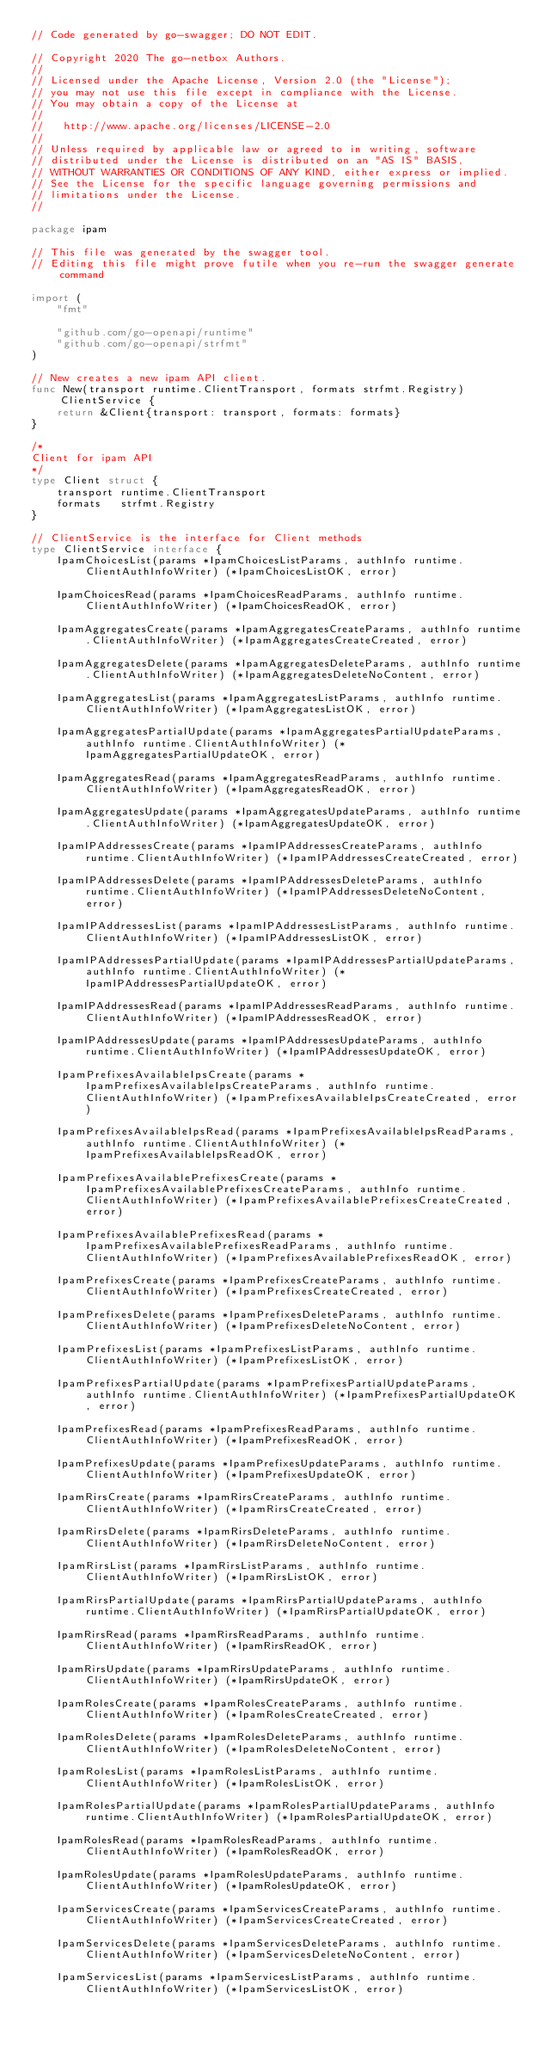<code> <loc_0><loc_0><loc_500><loc_500><_Go_>// Code generated by go-swagger; DO NOT EDIT.

// Copyright 2020 The go-netbox Authors.
//
// Licensed under the Apache License, Version 2.0 (the "License");
// you may not use this file except in compliance with the License.
// You may obtain a copy of the License at
//
//   http://www.apache.org/licenses/LICENSE-2.0
//
// Unless required by applicable law or agreed to in writing, software
// distributed under the License is distributed on an "AS IS" BASIS,
// WITHOUT WARRANTIES OR CONDITIONS OF ANY KIND, either express or implied.
// See the License for the specific language governing permissions and
// limitations under the License.
//

package ipam

// This file was generated by the swagger tool.
// Editing this file might prove futile when you re-run the swagger generate command

import (
	"fmt"

	"github.com/go-openapi/runtime"
	"github.com/go-openapi/strfmt"
)

// New creates a new ipam API client.
func New(transport runtime.ClientTransport, formats strfmt.Registry) ClientService {
	return &Client{transport: transport, formats: formats}
}

/*
Client for ipam API
*/
type Client struct {
	transport runtime.ClientTransport
	formats   strfmt.Registry
}

// ClientService is the interface for Client methods
type ClientService interface {
	IpamChoicesList(params *IpamChoicesListParams, authInfo runtime.ClientAuthInfoWriter) (*IpamChoicesListOK, error)

	IpamChoicesRead(params *IpamChoicesReadParams, authInfo runtime.ClientAuthInfoWriter) (*IpamChoicesReadOK, error)

	IpamAggregatesCreate(params *IpamAggregatesCreateParams, authInfo runtime.ClientAuthInfoWriter) (*IpamAggregatesCreateCreated, error)

	IpamAggregatesDelete(params *IpamAggregatesDeleteParams, authInfo runtime.ClientAuthInfoWriter) (*IpamAggregatesDeleteNoContent, error)

	IpamAggregatesList(params *IpamAggregatesListParams, authInfo runtime.ClientAuthInfoWriter) (*IpamAggregatesListOK, error)

	IpamAggregatesPartialUpdate(params *IpamAggregatesPartialUpdateParams, authInfo runtime.ClientAuthInfoWriter) (*IpamAggregatesPartialUpdateOK, error)

	IpamAggregatesRead(params *IpamAggregatesReadParams, authInfo runtime.ClientAuthInfoWriter) (*IpamAggregatesReadOK, error)

	IpamAggregatesUpdate(params *IpamAggregatesUpdateParams, authInfo runtime.ClientAuthInfoWriter) (*IpamAggregatesUpdateOK, error)

	IpamIPAddressesCreate(params *IpamIPAddressesCreateParams, authInfo runtime.ClientAuthInfoWriter) (*IpamIPAddressesCreateCreated, error)

	IpamIPAddressesDelete(params *IpamIPAddressesDeleteParams, authInfo runtime.ClientAuthInfoWriter) (*IpamIPAddressesDeleteNoContent, error)

	IpamIPAddressesList(params *IpamIPAddressesListParams, authInfo runtime.ClientAuthInfoWriter) (*IpamIPAddressesListOK, error)

	IpamIPAddressesPartialUpdate(params *IpamIPAddressesPartialUpdateParams, authInfo runtime.ClientAuthInfoWriter) (*IpamIPAddressesPartialUpdateOK, error)

	IpamIPAddressesRead(params *IpamIPAddressesReadParams, authInfo runtime.ClientAuthInfoWriter) (*IpamIPAddressesReadOK, error)

	IpamIPAddressesUpdate(params *IpamIPAddressesUpdateParams, authInfo runtime.ClientAuthInfoWriter) (*IpamIPAddressesUpdateOK, error)

	IpamPrefixesAvailableIpsCreate(params *IpamPrefixesAvailableIpsCreateParams, authInfo runtime.ClientAuthInfoWriter) (*IpamPrefixesAvailableIpsCreateCreated, error)

	IpamPrefixesAvailableIpsRead(params *IpamPrefixesAvailableIpsReadParams, authInfo runtime.ClientAuthInfoWriter) (*IpamPrefixesAvailableIpsReadOK, error)

	IpamPrefixesAvailablePrefixesCreate(params *IpamPrefixesAvailablePrefixesCreateParams, authInfo runtime.ClientAuthInfoWriter) (*IpamPrefixesAvailablePrefixesCreateCreated, error)

	IpamPrefixesAvailablePrefixesRead(params *IpamPrefixesAvailablePrefixesReadParams, authInfo runtime.ClientAuthInfoWriter) (*IpamPrefixesAvailablePrefixesReadOK, error)

	IpamPrefixesCreate(params *IpamPrefixesCreateParams, authInfo runtime.ClientAuthInfoWriter) (*IpamPrefixesCreateCreated, error)

	IpamPrefixesDelete(params *IpamPrefixesDeleteParams, authInfo runtime.ClientAuthInfoWriter) (*IpamPrefixesDeleteNoContent, error)

	IpamPrefixesList(params *IpamPrefixesListParams, authInfo runtime.ClientAuthInfoWriter) (*IpamPrefixesListOK, error)

	IpamPrefixesPartialUpdate(params *IpamPrefixesPartialUpdateParams, authInfo runtime.ClientAuthInfoWriter) (*IpamPrefixesPartialUpdateOK, error)

	IpamPrefixesRead(params *IpamPrefixesReadParams, authInfo runtime.ClientAuthInfoWriter) (*IpamPrefixesReadOK, error)

	IpamPrefixesUpdate(params *IpamPrefixesUpdateParams, authInfo runtime.ClientAuthInfoWriter) (*IpamPrefixesUpdateOK, error)

	IpamRirsCreate(params *IpamRirsCreateParams, authInfo runtime.ClientAuthInfoWriter) (*IpamRirsCreateCreated, error)

	IpamRirsDelete(params *IpamRirsDeleteParams, authInfo runtime.ClientAuthInfoWriter) (*IpamRirsDeleteNoContent, error)

	IpamRirsList(params *IpamRirsListParams, authInfo runtime.ClientAuthInfoWriter) (*IpamRirsListOK, error)

	IpamRirsPartialUpdate(params *IpamRirsPartialUpdateParams, authInfo runtime.ClientAuthInfoWriter) (*IpamRirsPartialUpdateOK, error)

	IpamRirsRead(params *IpamRirsReadParams, authInfo runtime.ClientAuthInfoWriter) (*IpamRirsReadOK, error)

	IpamRirsUpdate(params *IpamRirsUpdateParams, authInfo runtime.ClientAuthInfoWriter) (*IpamRirsUpdateOK, error)

	IpamRolesCreate(params *IpamRolesCreateParams, authInfo runtime.ClientAuthInfoWriter) (*IpamRolesCreateCreated, error)

	IpamRolesDelete(params *IpamRolesDeleteParams, authInfo runtime.ClientAuthInfoWriter) (*IpamRolesDeleteNoContent, error)

	IpamRolesList(params *IpamRolesListParams, authInfo runtime.ClientAuthInfoWriter) (*IpamRolesListOK, error)

	IpamRolesPartialUpdate(params *IpamRolesPartialUpdateParams, authInfo runtime.ClientAuthInfoWriter) (*IpamRolesPartialUpdateOK, error)

	IpamRolesRead(params *IpamRolesReadParams, authInfo runtime.ClientAuthInfoWriter) (*IpamRolesReadOK, error)

	IpamRolesUpdate(params *IpamRolesUpdateParams, authInfo runtime.ClientAuthInfoWriter) (*IpamRolesUpdateOK, error)

	IpamServicesCreate(params *IpamServicesCreateParams, authInfo runtime.ClientAuthInfoWriter) (*IpamServicesCreateCreated, error)

	IpamServicesDelete(params *IpamServicesDeleteParams, authInfo runtime.ClientAuthInfoWriter) (*IpamServicesDeleteNoContent, error)

	IpamServicesList(params *IpamServicesListParams, authInfo runtime.ClientAuthInfoWriter) (*IpamServicesListOK, error)
</code> 